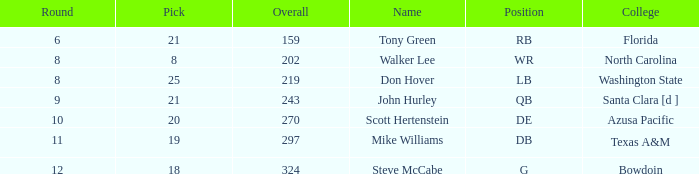Which university has a selection below 25, a total higher than 159, a round under 10, and a wide receiver as the position? North Carolina. 